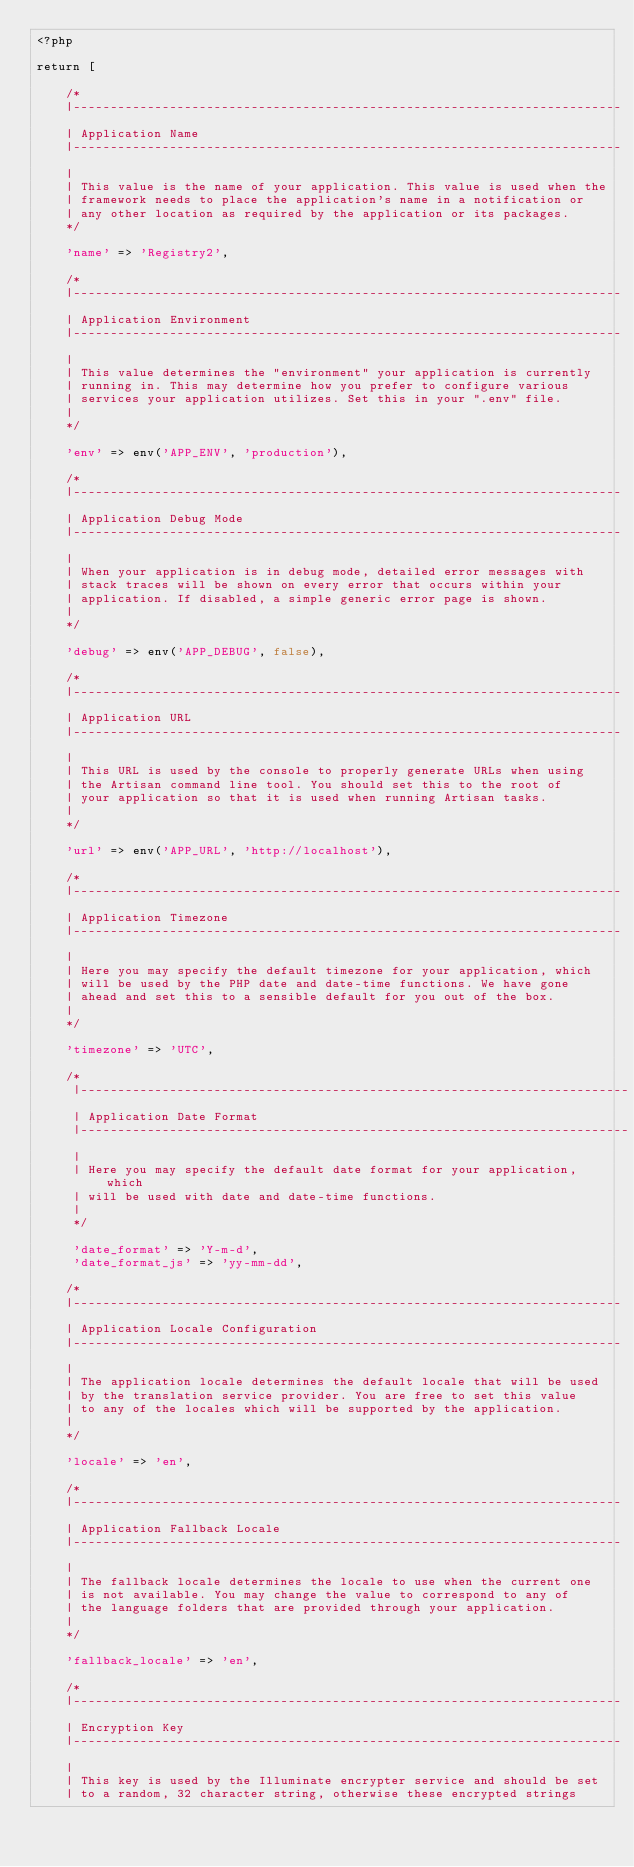Convert code to text. <code><loc_0><loc_0><loc_500><loc_500><_PHP_><?php

return [

    /*
    |--------------------------------------------------------------------------
    | Application Name
    |--------------------------------------------------------------------------
    |
    | This value is the name of your application. This value is used when the
    | framework needs to place the application's name in a notification or
    | any other location as required by the application or its packages.
    */

    'name' => 'Registry2',

    /*
    |--------------------------------------------------------------------------
    | Application Environment
    |--------------------------------------------------------------------------
    |
    | This value determines the "environment" your application is currently
    | running in. This may determine how you prefer to configure various
    | services your application utilizes. Set this in your ".env" file.
    |
    */

    'env' => env('APP_ENV', 'production'),

    /*
    |--------------------------------------------------------------------------
    | Application Debug Mode
    |--------------------------------------------------------------------------
    |
    | When your application is in debug mode, detailed error messages with
    | stack traces will be shown on every error that occurs within your
    | application. If disabled, a simple generic error page is shown.
    |
    */

    'debug' => env('APP_DEBUG', false),

    /*
    |--------------------------------------------------------------------------
    | Application URL
    |--------------------------------------------------------------------------
    |
    | This URL is used by the console to properly generate URLs when using
    | the Artisan command line tool. You should set this to the root of
    | your application so that it is used when running Artisan tasks.
    |
    */

    'url' => env('APP_URL', 'http://localhost'),

    /*
    |--------------------------------------------------------------------------
    | Application Timezone
    |--------------------------------------------------------------------------
    |
    | Here you may specify the default timezone for your application, which
    | will be used by the PHP date and date-time functions. We have gone
    | ahead and set this to a sensible default for you out of the box.
    |
    */

    'timezone' => 'UTC',

    /*
     |--------------------------------------------------------------------------
     | Application Date Format
     |--------------------------------------------------------------------------
     |
     | Here you may specify the default date format for your application, which
     | will be used with date and date-time functions.
     |
     */

     'date_format' => 'Y-m-d',
     'date_format_js' => 'yy-mm-dd',

    /*
    |--------------------------------------------------------------------------
    | Application Locale Configuration
    |--------------------------------------------------------------------------
    |
    | The application locale determines the default locale that will be used
    | by the translation service provider. You are free to set this value
    | to any of the locales which will be supported by the application.
    |
    */

    'locale' => 'en',

    /*
    |--------------------------------------------------------------------------
    | Application Fallback Locale
    |--------------------------------------------------------------------------
    |
    | The fallback locale determines the locale to use when the current one
    | is not available. You may change the value to correspond to any of
    | the language folders that are provided through your application.
    |
    */

    'fallback_locale' => 'en',

    /*
    |--------------------------------------------------------------------------
    | Encryption Key
    |--------------------------------------------------------------------------
    |
    | This key is used by the Illuminate encrypter service and should be set
    | to a random, 32 character string, otherwise these encrypted strings</code> 